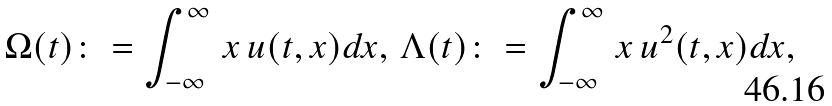<formula> <loc_0><loc_0><loc_500><loc_500>\Omega ( t ) \colon = \int _ { - \infty } ^ { \infty } \, x \, u ( t , x ) d x , \, \Lambda ( t ) \colon = \int _ { - \infty } ^ { \infty } \, x \, u ^ { 2 } ( t , x ) d x ,</formula> 